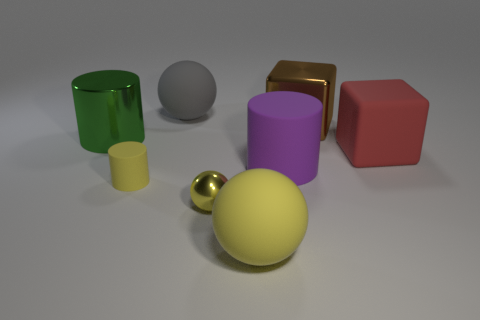Is the color of the tiny matte cylinder the same as the big matte sphere that is behind the large yellow rubber sphere?
Provide a short and direct response. No. What material is the brown cube that is right of the tiny yellow thing left of the large rubber thing that is behind the big green object?
Your response must be concise. Metal. What shape is the big rubber thing behind the red matte object?
Give a very brief answer. Sphere. What size is the yellow thing that is made of the same material as the brown cube?
Your answer should be very brief. Small. What number of other tiny things have the same shape as the yellow metallic object?
Keep it short and to the point. 0. There is a big metallic object in front of the big brown shiny object; is its color the same as the big metal block?
Keep it short and to the point. No. There is a big cube that is in front of the metallic cylinder in front of the gray matte object; how many small matte objects are behind it?
Your answer should be compact. 0. What number of big things are left of the large matte cube and behind the purple rubber thing?
Offer a very short reply. 3. There is a small shiny object that is the same color as the tiny cylinder; what shape is it?
Offer a terse response. Sphere. Are there any other things that have the same material as the big gray sphere?
Offer a terse response. Yes. 